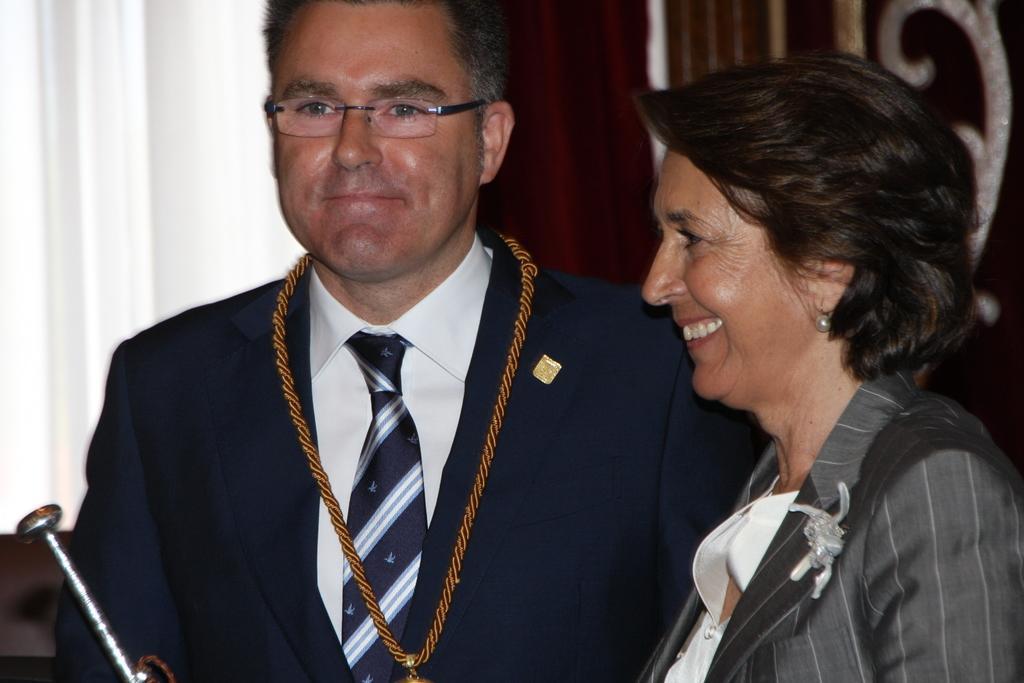In one or two sentences, can you explain what this image depicts? In this image there are four people standing one in the middle and one on the right. 